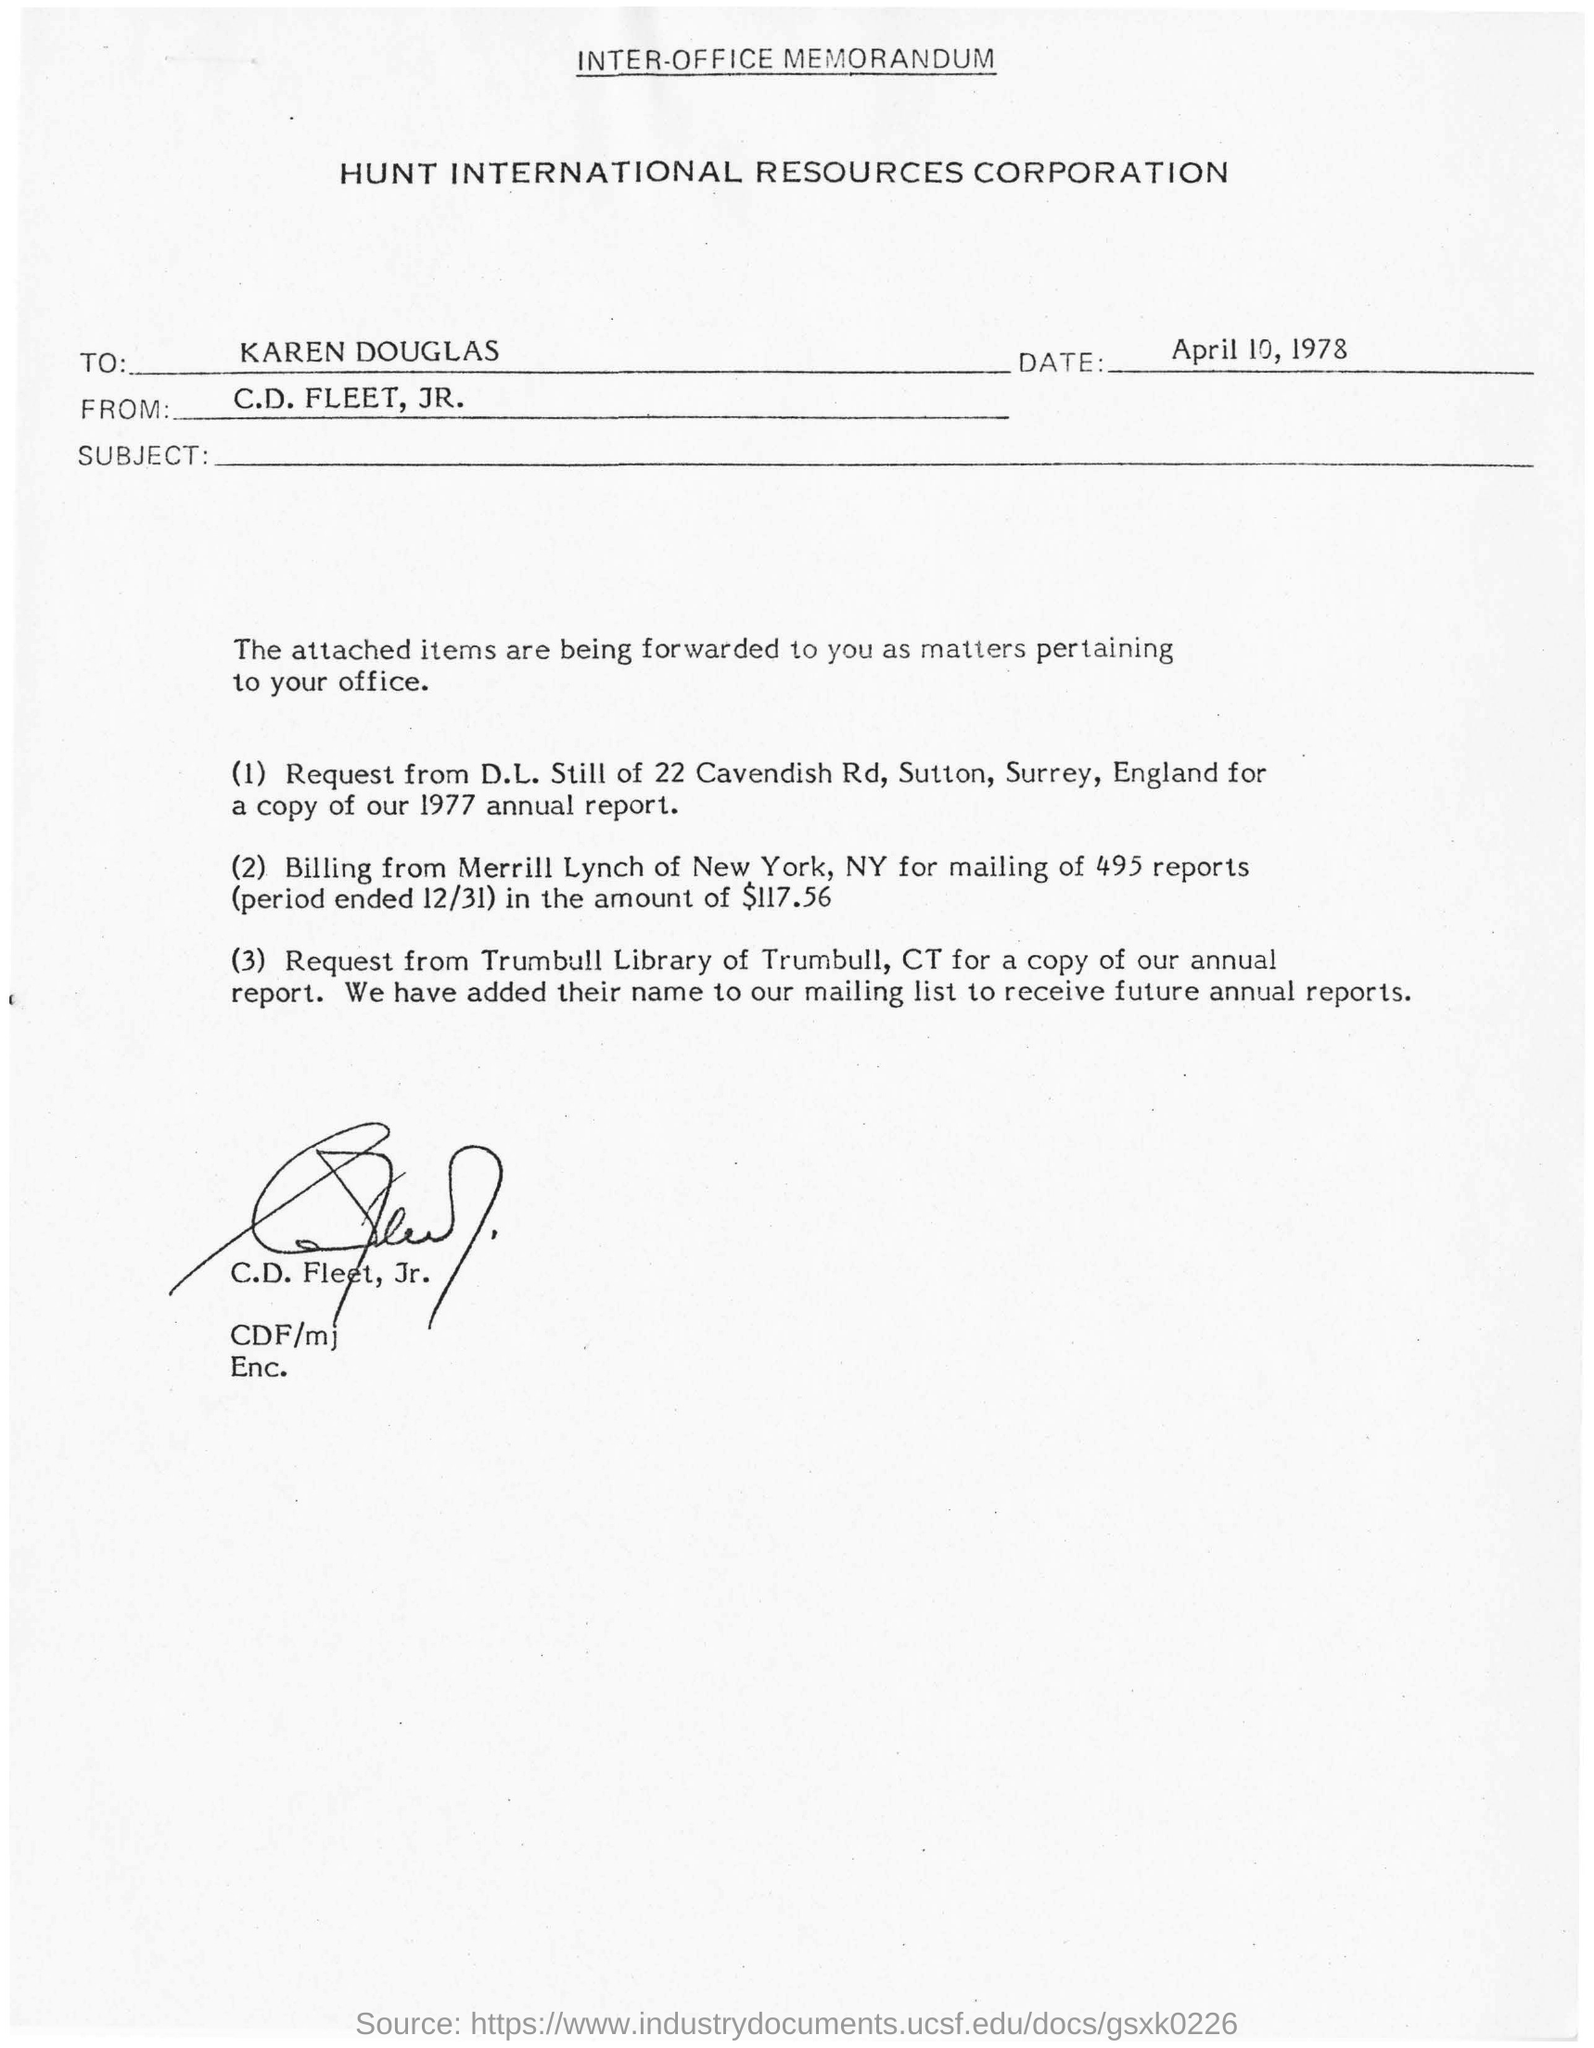Highlight a few significant elements in this photo. The sender of this memorandum is C.D. Fleet, Jr. The date mentioned is April 10, 1978. C.D. Fleet, Jr. has written this document. 